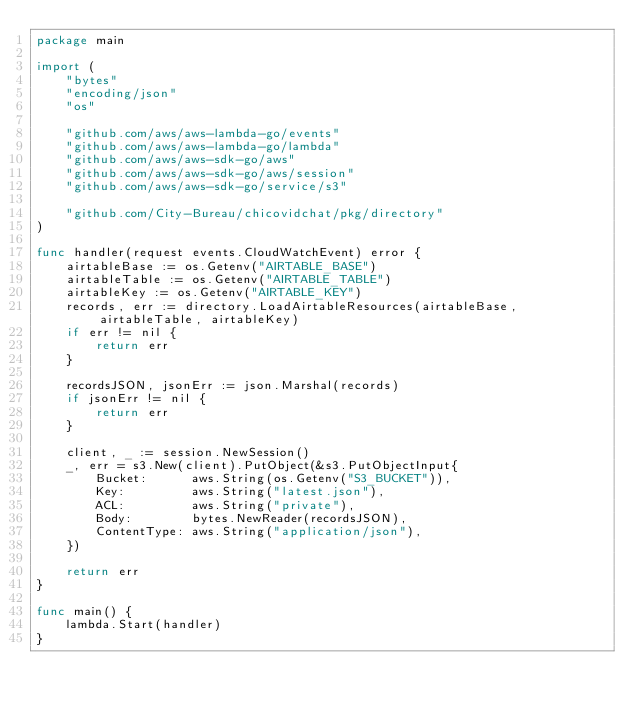Convert code to text. <code><loc_0><loc_0><loc_500><loc_500><_Go_>package main

import (
	"bytes"
	"encoding/json"
	"os"

	"github.com/aws/aws-lambda-go/events"
	"github.com/aws/aws-lambda-go/lambda"
	"github.com/aws/aws-sdk-go/aws"
	"github.com/aws/aws-sdk-go/aws/session"
	"github.com/aws/aws-sdk-go/service/s3"

	"github.com/City-Bureau/chicovidchat/pkg/directory"
)

func handler(request events.CloudWatchEvent) error {
	airtableBase := os.Getenv("AIRTABLE_BASE")
	airtableTable := os.Getenv("AIRTABLE_TABLE")
	airtableKey := os.Getenv("AIRTABLE_KEY")
	records, err := directory.LoadAirtableResources(airtableBase, airtableTable, airtableKey)
	if err != nil {
		return err
	}

	recordsJSON, jsonErr := json.Marshal(records)
	if jsonErr != nil {
		return err
	}

	client, _ := session.NewSession()
	_, err = s3.New(client).PutObject(&s3.PutObjectInput{
		Bucket:      aws.String(os.Getenv("S3_BUCKET")),
		Key:         aws.String("latest.json"),
		ACL:         aws.String("private"),
		Body:        bytes.NewReader(recordsJSON),
		ContentType: aws.String("application/json"),
	})

	return err
}

func main() {
	lambda.Start(handler)
}
</code> 